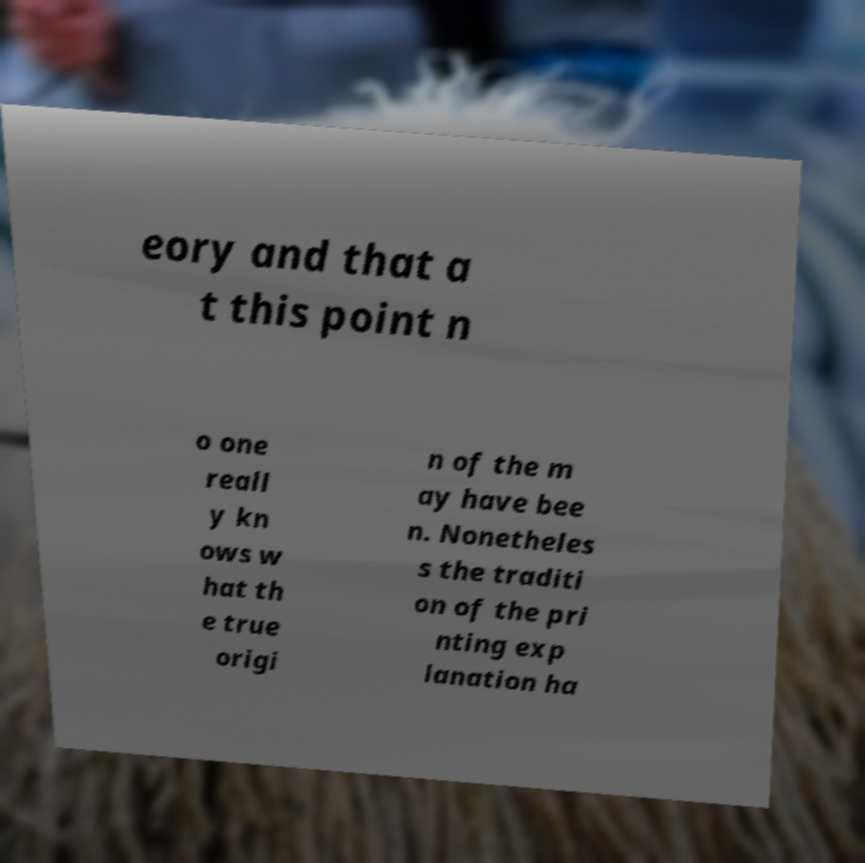I need the written content from this picture converted into text. Can you do that? eory and that a t this point n o one reall y kn ows w hat th e true origi n of the m ay have bee n. Nonetheles s the traditi on of the pri nting exp lanation ha 